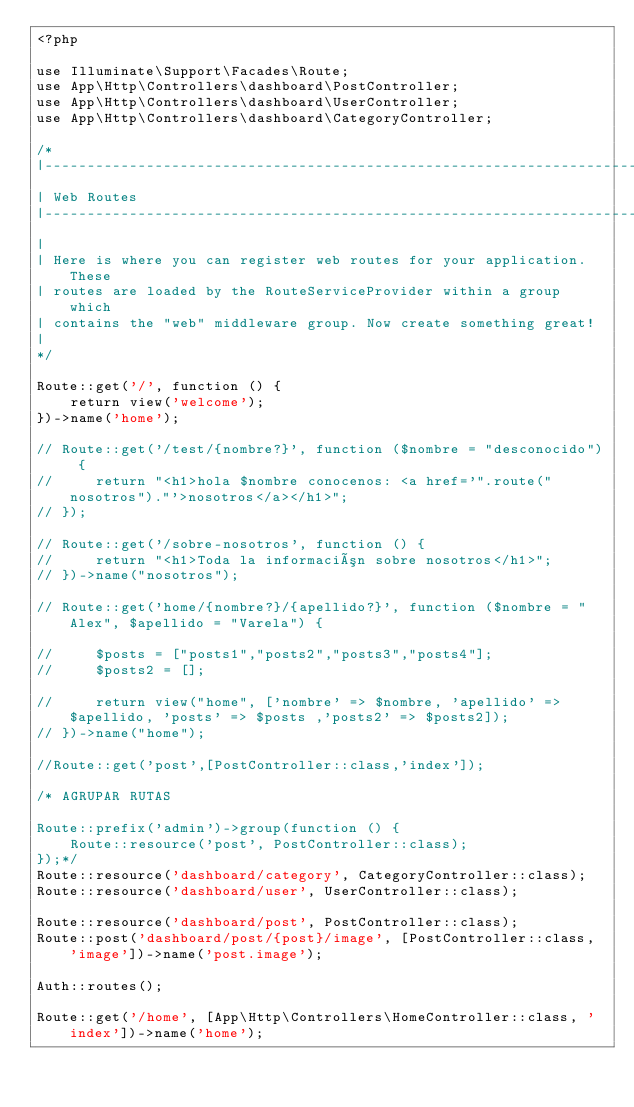<code> <loc_0><loc_0><loc_500><loc_500><_PHP_><?php

use Illuminate\Support\Facades\Route;
use App\Http\Controllers\dashboard\PostController;
use App\Http\Controllers\dashboard\UserController;
use App\Http\Controllers\dashboard\CategoryController;

/*
|--------------------------------------------------------------------------
| Web Routes
|--------------------------------------------------------------------------
|
| Here is where you can register web routes for your application. These
| routes are loaded by the RouteServiceProvider within a group which
| contains the "web" middleware group. Now create something great!
|
*/

Route::get('/', function () {
    return view('welcome');
})->name('home');

// Route::get('/test/{nombre?}', function ($nombre = "desconocido") {
//     return "<h1>hola $nombre conocenos: <a href='".route("nosotros")."'>nosotros</a></h1>";
// });

// Route::get('/sobre-nosotros', function () {
//     return "<h1>Toda la información sobre nosotros</h1>";
// })->name("nosotros");

// Route::get('home/{nombre?}/{apellido?}', function ($nombre = "Alex", $apellido = "Varela") {

//     $posts = ["posts1","posts2","posts3","posts4"];
//     $posts2 = [];

//     return view("home", ['nombre' => $nombre, 'apellido' => $apellido, 'posts' => $posts ,'posts2' => $posts2]); 
// })->name("home");

//Route::get('post',[PostController::class,'index']);

/* AGRUPAR RUTAS

Route::prefix('admin')->group(function () {
    Route::resource('post', PostController::class);
});*/
Route::resource('dashboard/category', CategoryController::class); 
Route::resource('dashboard/user', UserController::class);

Route::resource('dashboard/post', PostController::class);
Route::post('dashboard/post/{post}/image', [PostController::class, 'image'])->name('post.image');

Auth::routes();

Route::get('/home', [App\Http\Controllers\HomeController::class, 'index'])->name('home');

</code> 